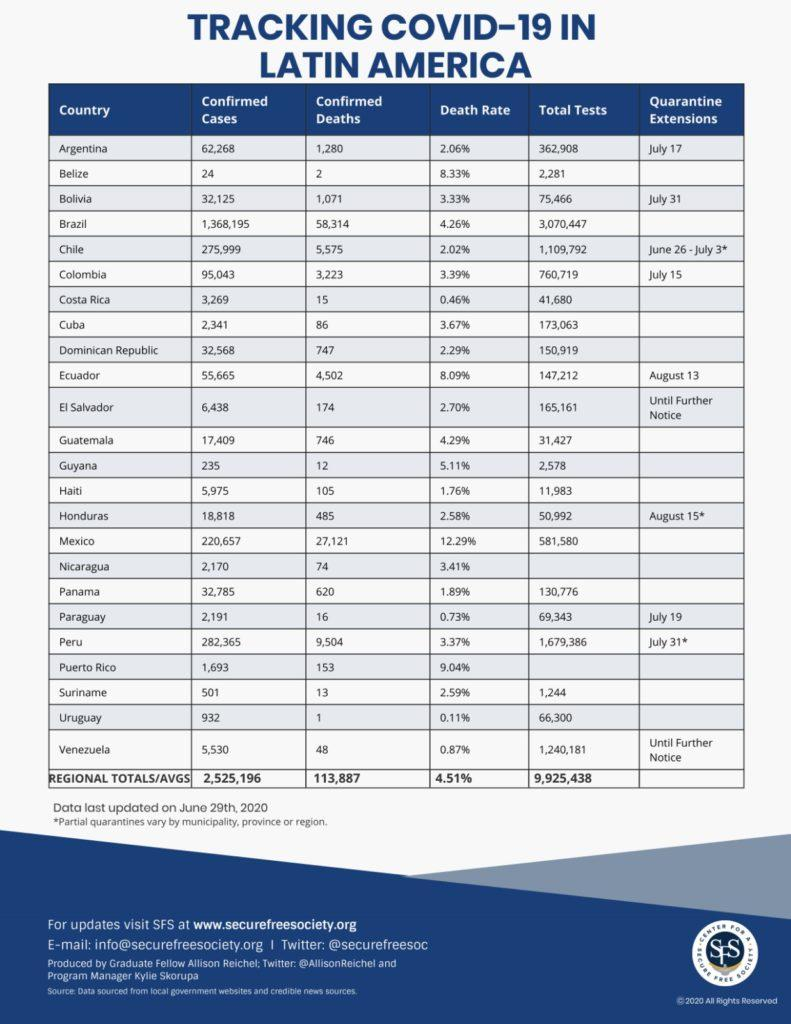Identify some key points in this picture. As of June 29, 2020, the confirmed number of COVID-19 deaths in Latin America was 113,887. As of June 29, 2020, Brazil reported the highest number of COVID-19 cases among all countries in Latin America. As of June 29, 2020, the average number of COVID-19 tests conducted in Latin America was 9,925,438. As of June 29, 2020, a total of 581,580 COVID-19 tests had been conducted in Mexico. Paraguay has a quarantine extension of July 19.. 